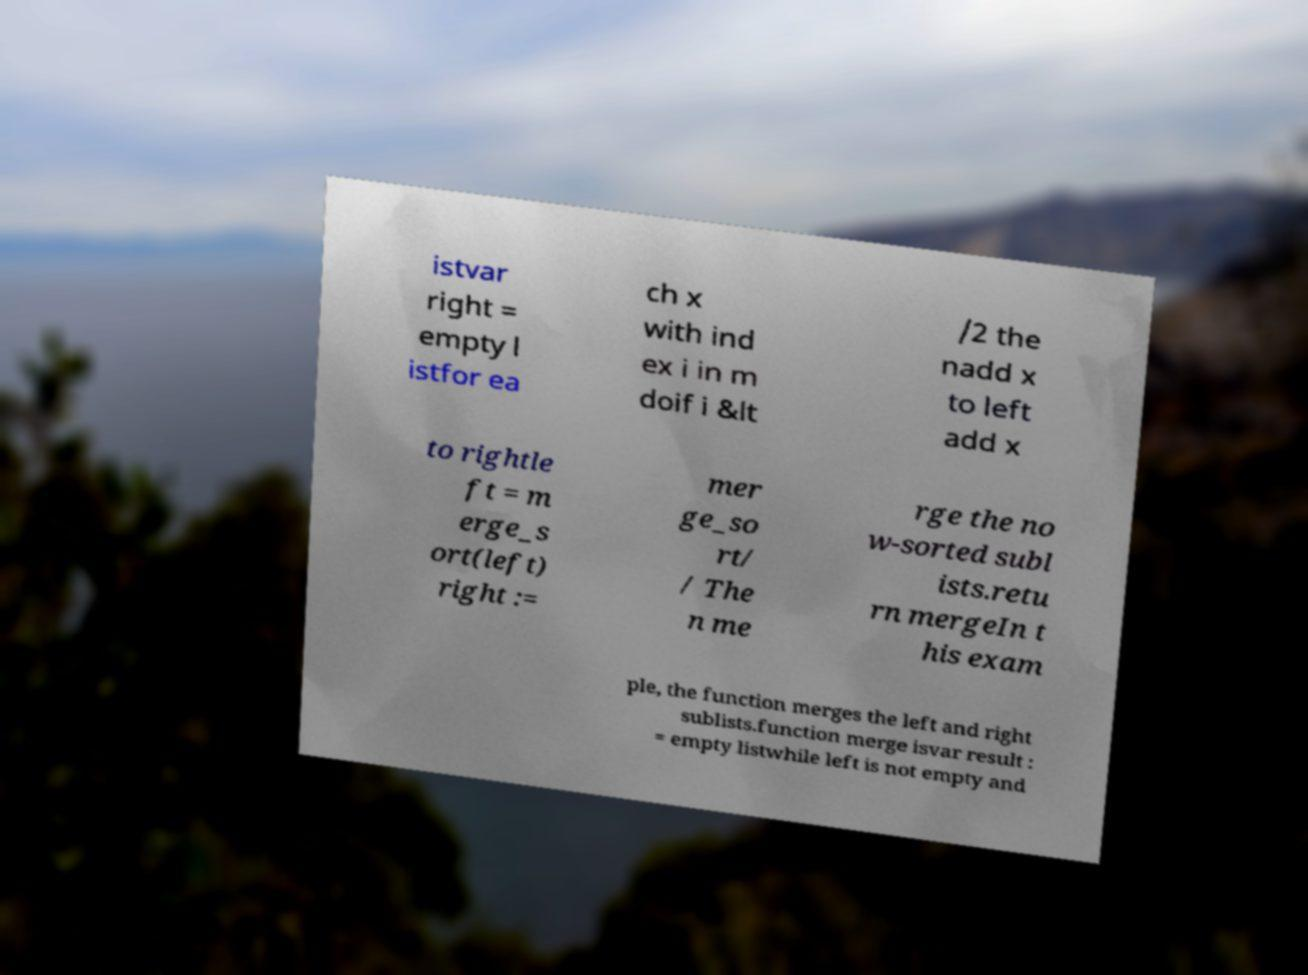There's text embedded in this image that I need extracted. Can you transcribe it verbatim? istvar right = empty l istfor ea ch x with ind ex i in m doif i &lt /2 the nadd x to left add x to rightle ft = m erge_s ort(left) right := mer ge_so rt/ / The n me rge the no w-sorted subl ists.retu rn mergeIn t his exam ple, the function merges the left and right sublists.function merge isvar result : = empty listwhile left is not empty and 